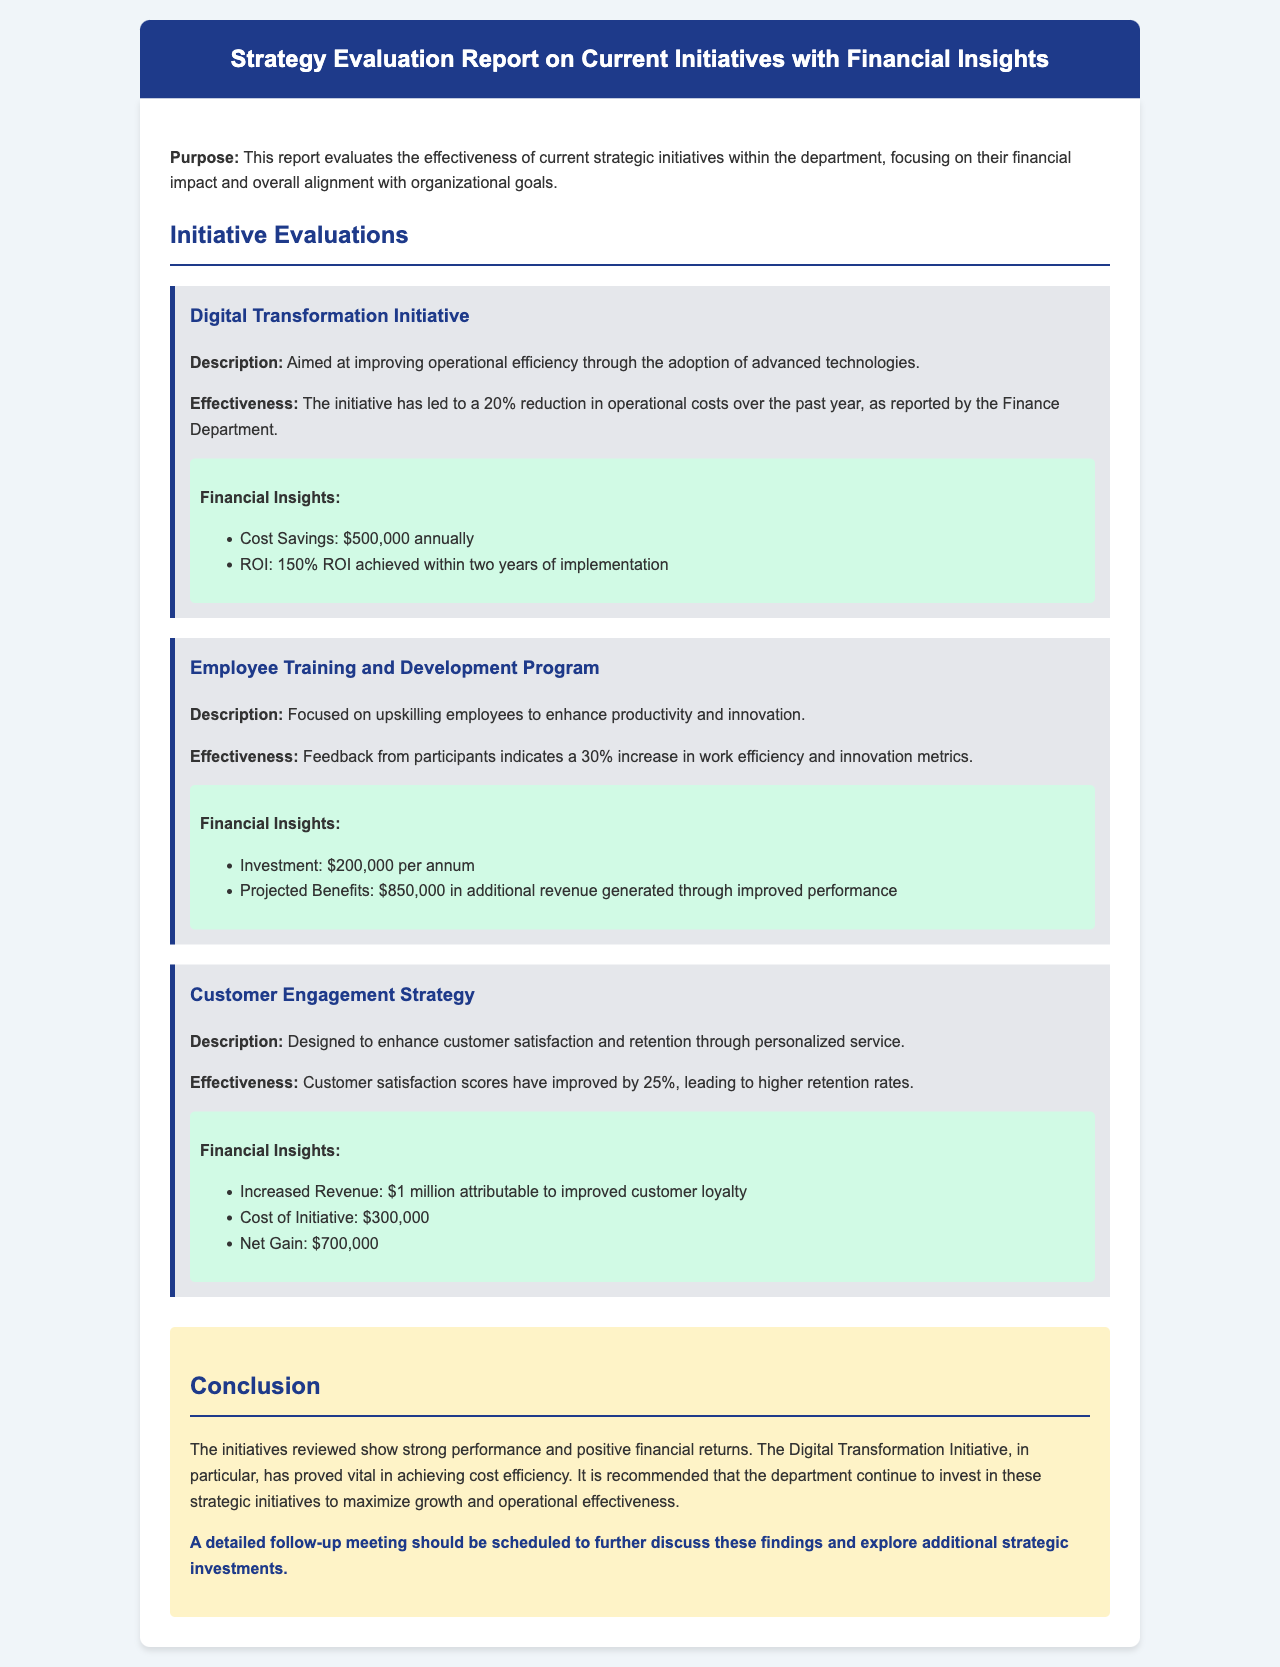What is the purpose of the report? The purpose of the report is to evaluate the effectiveness of current strategic initiatives within the department, focusing on their financial impact and overall alignment with organizational goals.
Answer: Evaluate effectiveness What is the annual cost savings from the Digital Transformation Initiative? The annual cost savings from the Digital Transformation Initiative is directly mentioned in the financial insights, which states it is $500,000.
Answer: $500,000 What percentage increase in customer satisfaction was achieved through the Customer Engagement Strategy? The report states that customer satisfaction scores have improved by 25%, indicating the percentage increase achieved.
Answer: 25% What is the total projected benefit from the Employee Training and Development Program? The projected benefits are noted to be $850,000 in additional revenue generated through improved performance as per the financial insights.
Answer: $850,000 What is the net gain from the Customer Engagement Strategy initiative? The net gain is calculated by subtracting the cost of the initiative from the increased revenue, which amounts to $700,000 as mentioned in the financial insights.
Answer: $700,000 What initiative achieved a 150% ROI? The initiative that achieved a 150% ROI is explicitly mentioned in the financial insights of the Digital Transformation Initiative.
Answer: Digital Transformation Initiative What should be scheduled to discuss the findings? The document suggests that a detailed follow-up meeting should be scheduled to further discuss the findings.
Answer: Detailed follow-up meeting What financial insight is associated with the Employee Training and Development Program? The financial insight associated with this program includes an investment of $200,000 per annum as stated in the financial insights section.
Answer: $200,000 per annum Which initiative is recommended for continued investment? The report recommends continued investment in the Digital Transformation Initiative due to its vital role in achieving cost efficiency.
Answer: Digital Transformation Initiative 